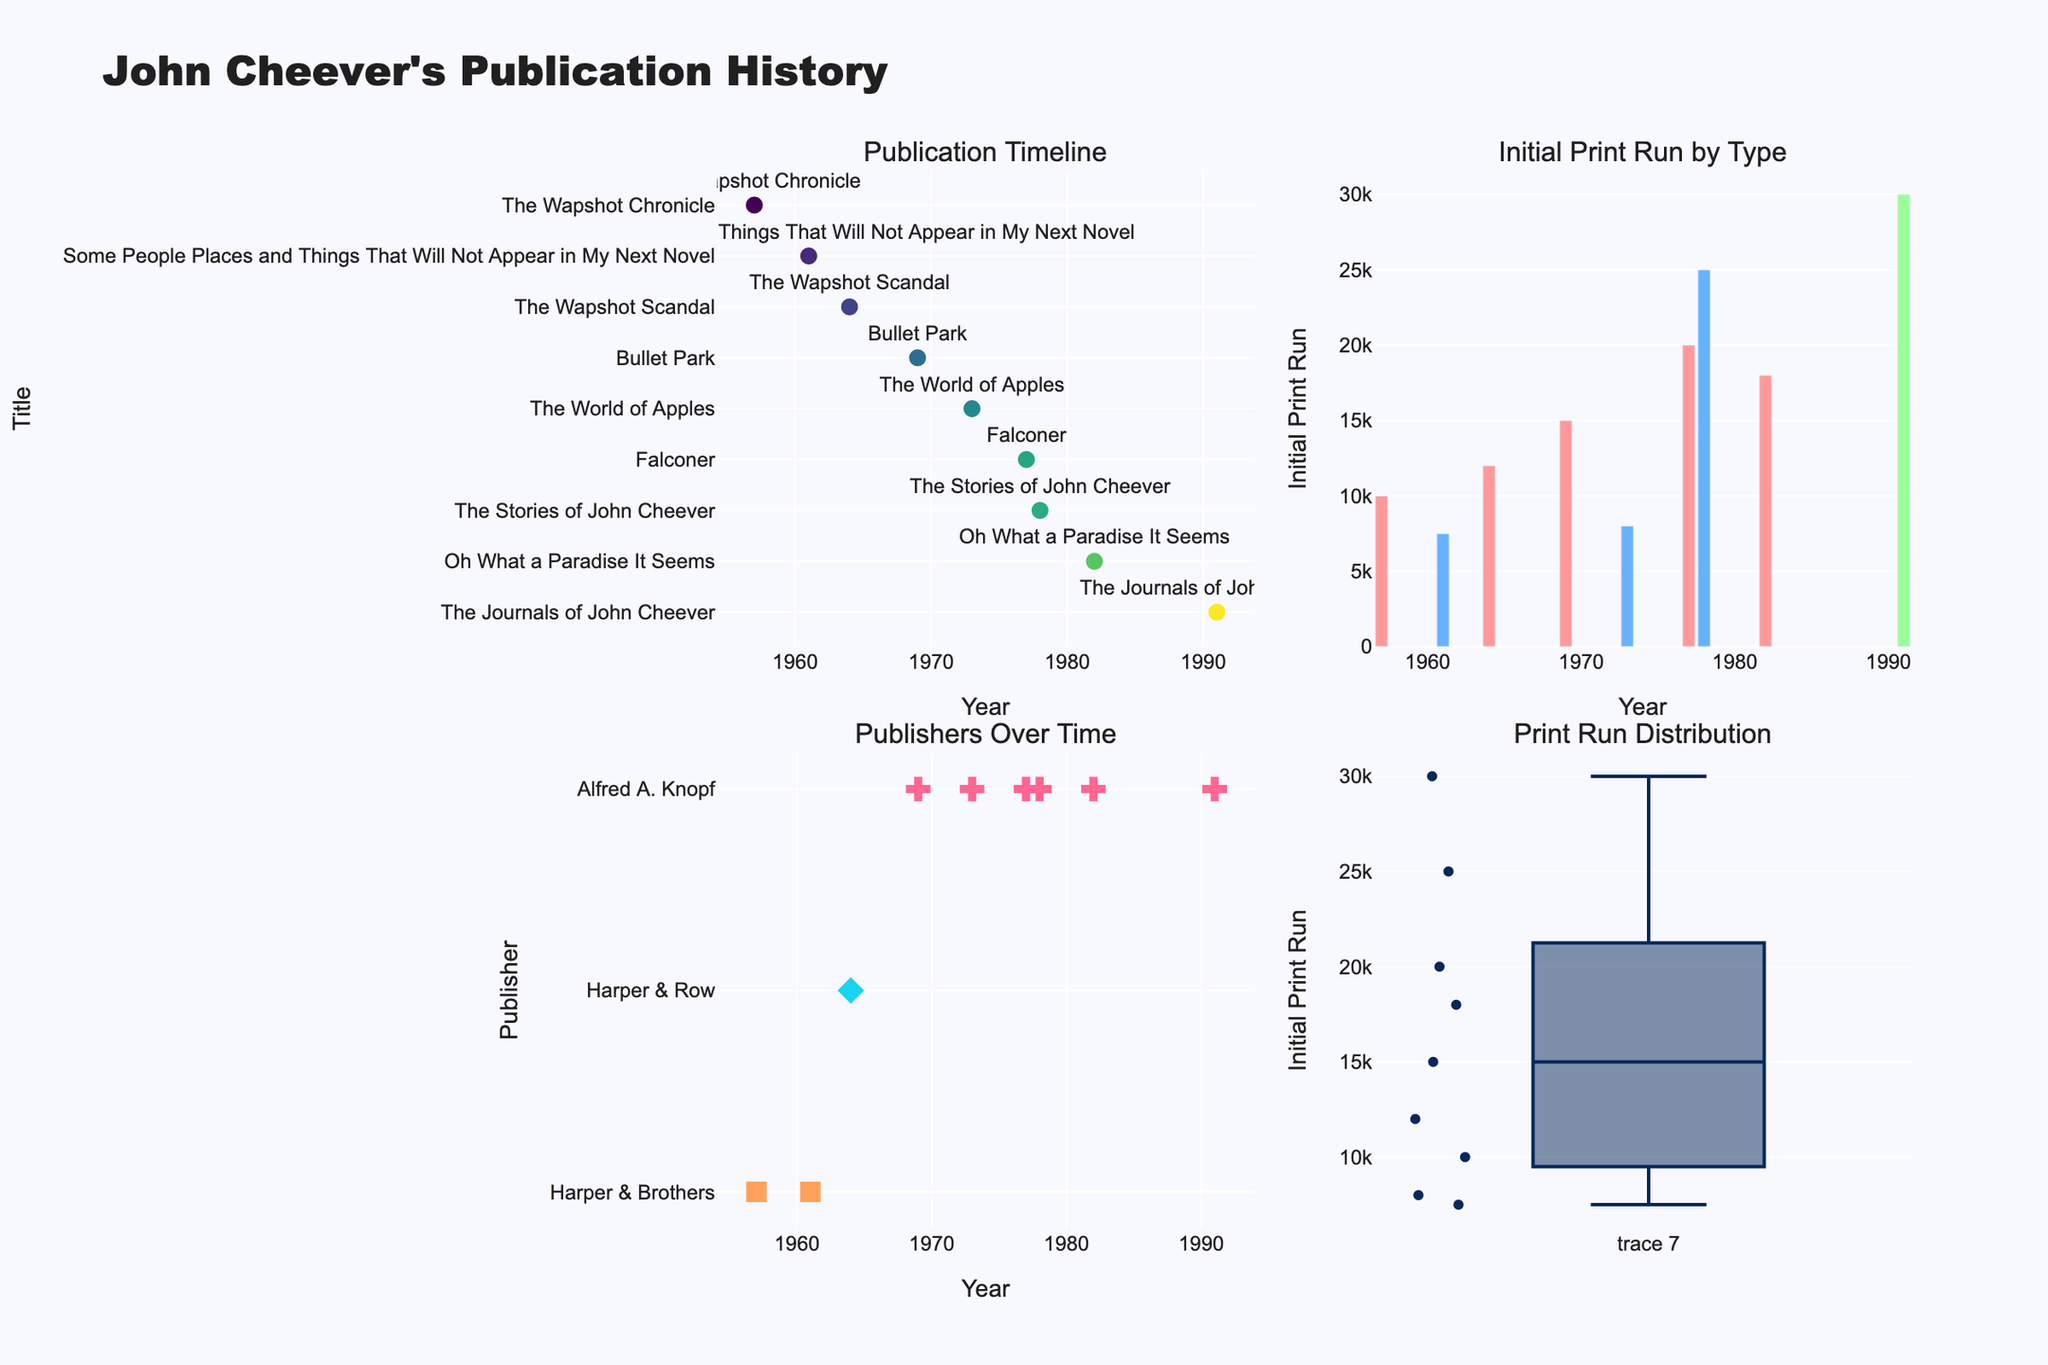What is the title of the figure? The title of the figure is displayed at the top center of the visual and reads "Time Allocation for Working Mothers".
Answer: Time Allocation for Working Mothers Which activity occupies the most hours per week in the scatter plot? To find the activity with the most hours per week, look at the y-axis scale in the scatter plot and identify the data point with the highest y-value. Sleep is the activity with 49 hours per week.
Answer: Sleep What percentage of the week is dedicated to College Application Tasks according to the pie chart? In the pie chart titled "Work-Family-Education Balance", look at the slice labeled "College Application Tasks". The label indicates it occupies 6.0% of the week.
Answer: 6.0% How many hours per week are allocated to personal activities according to the bar chart? In the bar chart titled "Personal Activities", find the y-values for each personal activity (Family Time, Childcare, Sleep, Household Chores, Self-Care, Community Involvement), and sum them up. The total is 25 + 20 + 49 + 10 + 3 + 2 = 109 hours.
Answer: 109 hours Which category has the most diverse set of activities in the treemap? In the treemap titled "Time Allocation Overview", observe the number of unique labels associated with each color indicating different categories. The Personal category has the most diverse set of activities.
Answer: Personal Compare the hours allocated to Work and to Family Time. Which is higher? In both the pie chart and the scatter plot, compare the values associated with Work and Family Time. Work is allocated 30 hours per week, while Family Time is allocated 25 hours per week. Work has higher hours.
Answer: Work Rank the educational activities by hours per week from highest to lowest. In either the pie chart or the scatter plot, identify the educational activities (College Application Tasks and Studying) and their corresponding hours. Rank them: 5 hours for College Application Tasks and 3 hours for Studying.
Answer: College Application Tasks, Studying If a working mother wants to allocate equal time to Family Time and Sleep, how many hours would she need to adjust from Sleep? She currently allocates 49 hours to Sleep and 25 hours to Family Time. To make them equal, she needs to allocate 37 hours to each (since (49+25)/2 = 37). This requires moving 12 hours from Sleep to Family Time.
Answer: 12 hours What proportion of the total weekly hours is spent on Household Chores according to the treemap? In the treemap, find the section labeled "Household Chores" and its value (10 hours). The total weekly hours in the dataset is the sum of all hours, 147. The proportion is 10/147 ≈ 0.068 or 6.8%.
Answer: 6.8% 